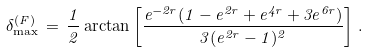Convert formula to latex. <formula><loc_0><loc_0><loc_500><loc_500>\delta _ { \max } ^ { ( F ) } \, = \, \frac { 1 } { 2 } \arctan \left [ \frac { e ^ { - 2 r } ( 1 - e ^ { 2 r } + e ^ { 4 r } + 3 e ^ { 6 r } ) } { 3 ( e ^ { 2 r } - 1 ) ^ { 2 } } \right ] \, .</formula> 